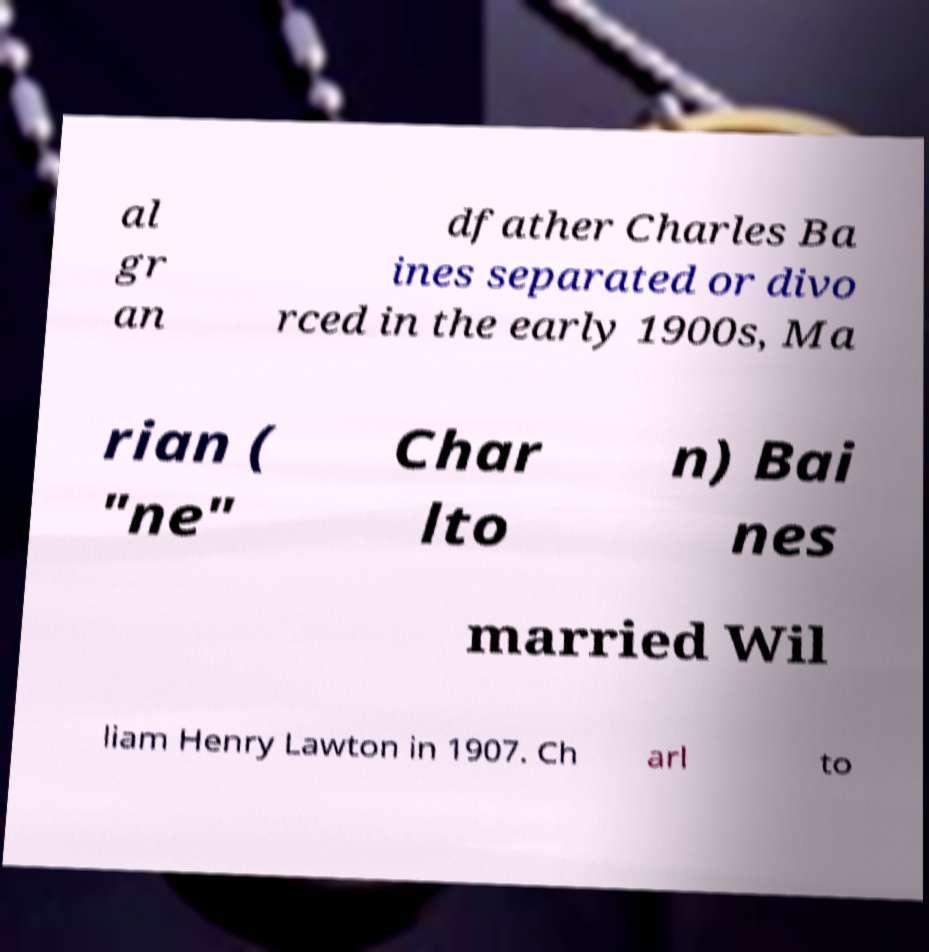What messages or text are displayed in this image? I need them in a readable, typed format. al gr an dfather Charles Ba ines separated or divo rced in the early 1900s, Ma rian ( "ne" Char lto n) Bai nes married Wil liam Henry Lawton in 1907. Ch arl to 